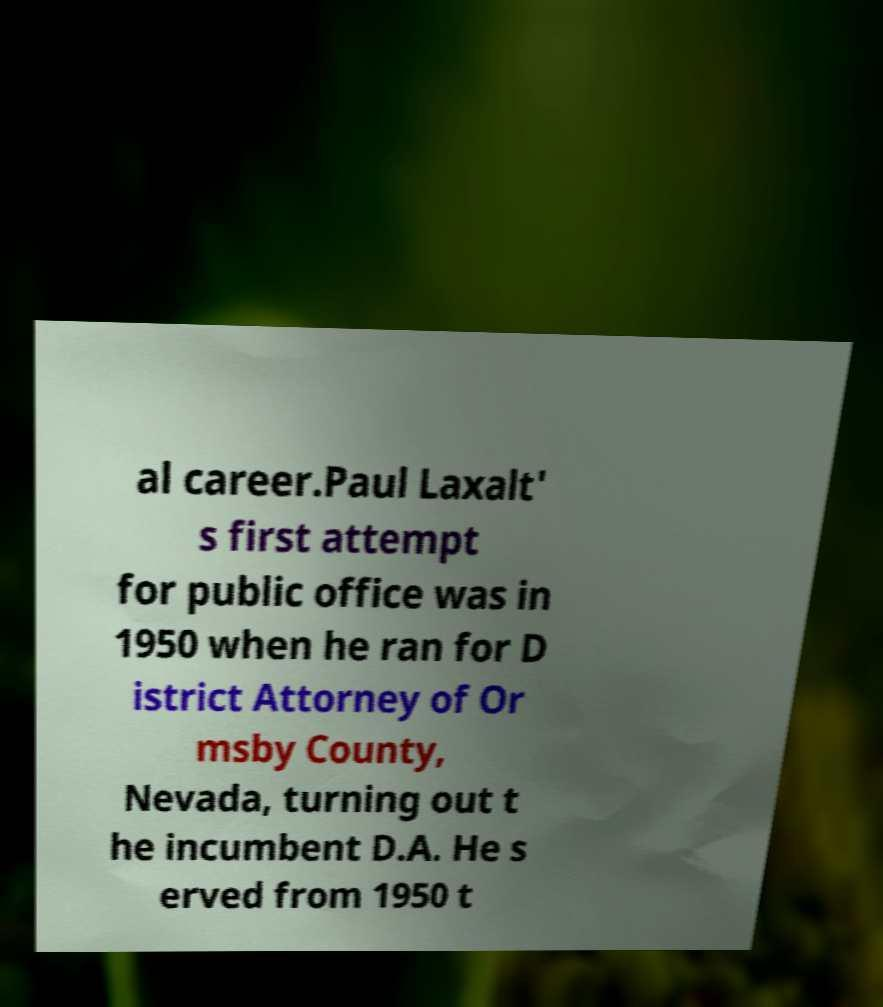Please identify and transcribe the text found in this image. al career.Paul Laxalt' s first attempt for public office was in 1950 when he ran for D istrict Attorney of Or msby County, Nevada, turning out t he incumbent D.A. He s erved from 1950 t 